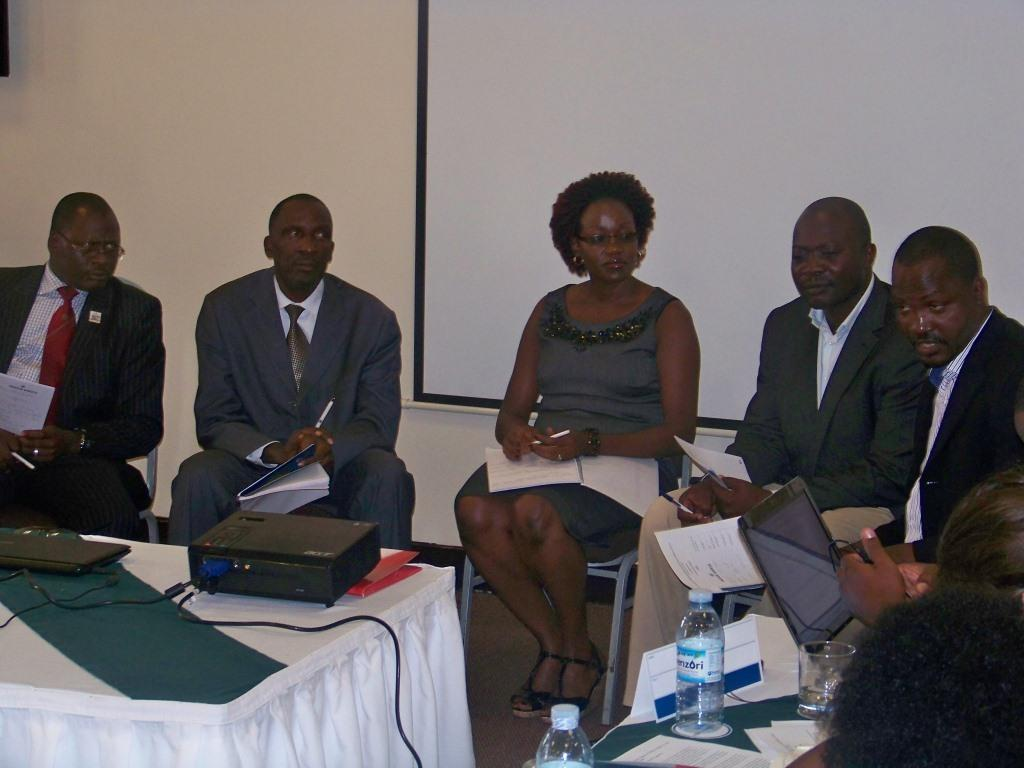What are the people in the image doing? The people in the image are sitting in a group. What are the people sitting on? The people are sitting on chairs. What objects are the people holding? The people are holding books and pens. What electronic devices are on the table? There are laptops on the table. What is the purpose of the projector on the table? The projector is likely used for displaying visuals during a presentation or meeting. What other items can be seen on the table? There are papers, a glass, and a bottle on the table. What can be seen in the background of the image? There is a wall and a banner in the background. How many planes can be seen flying in the image? There are no planes visible in the image. What type of watch is the person wearing in the image? There is no watch visible on any person in the image. 